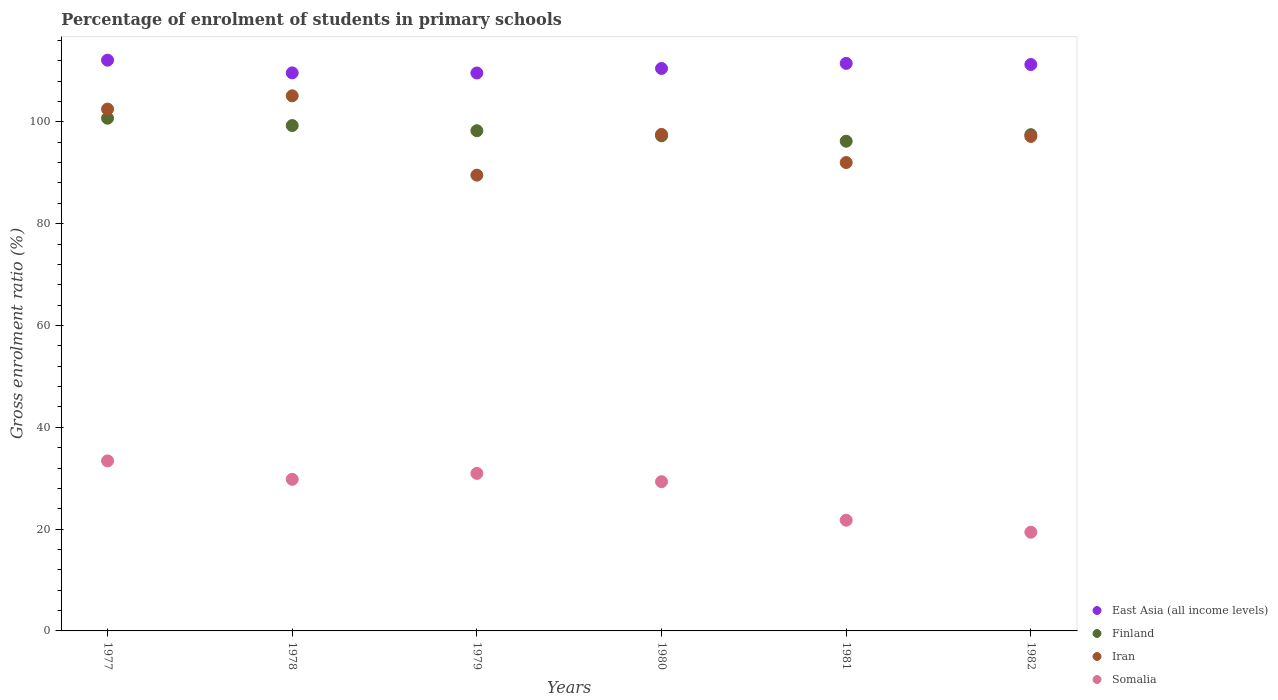What is the percentage of students enrolled in primary schools in East Asia (all income levels) in 1977?
Offer a terse response. 112.12. Across all years, what is the maximum percentage of students enrolled in primary schools in Iran?
Offer a terse response. 105.12. Across all years, what is the minimum percentage of students enrolled in primary schools in Somalia?
Provide a succinct answer. 19.39. In which year was the percentage of students enrolled in primary schools in Iran minimum?
Keep it short and to the point. 1979. What is the total percentage of students enrolled in primary schools in Iran in the graph?
Your answer should be very brief. 583.87. What is the difference between the percentage of students enrolled in primary schools in Somalia in 1978 and that in 1980?
Provide a succinct answer. 0.47. What is the difference between the percentage of students enrolled in primary schools in East Asia (all income levels) in 1978 and the percentage of students enrolled in primary schools in Finland in 1980?
Provide a succinct answer. 12.36. What is the average percentage of students enrolled in primary schools in Somalia per year?
Your answer should be compact. 27.43. In the year 1982, what is the difference between the percentage of students enrolled in primary schools in Iran and percentage of students enrolled in primary schools in Somalia?
Give a very brief answer. 77.75. What is the ratio of the percentage of students enrolled in primary schools in East Asia (all income levels) in 1977 to that in 1981?
Provide a short and direct response. 1.01. What is the difference between the highest and the second highest percentage of students enrolled in primary schools in East Asia (all income levels)?
Your answer should be very brief. 0.63. What is the difference between the highest and the lowest percentage of students enrolled in primary schools in Finland?
Offer a terse response. 4.52. Is the sum of the percentage of students enrolled in primary schools in Iran in 1980 and 1982 greater than the maximum percentage of students enrolled in primary schools in East Asia (all income levels) across all years?
Ensure brevity in your answer.  Yes. Is it the case that in every year, the sum of the percentage of students enrolled in primary schools in Somalia and percentage of students enrolled in primary schools in Iran  is greater than the sum of percentage of students enrolled in primary schools in Finland and percentage of students enrolled in primary schools in East Asia (all income levels)?
Keep it short and to the point. Yes. Is the percentage of students enrolled in primary schools in Iran strictly greater than the percentage of students enrolled in primary schools in Finland over the years?
Keep it short and to the point. No. Is the percentage of students enrolled in primary schools in Finland strictly less than the percentage of students enrolled in primary schools in Iran over the years?
Keep it short and to the point. No. What is the difference between two consecutive major ticks on the Y-axis?
Give a very brief answer. 20. Are the values on the major ticks of Y-axis written in scientific E-notation?
Give a very brief answer. No. What is the title of the graph?
Your response must be concise. Percentage of enrolment of students in primary schools. Does "Mauritania" appear as one of the legend labels in the graph?
Keep it short and to the point. No. What is the label or title of the X-axis?
Provide a succinct answer. Years. What is the Gross enrolment ratio (%) of East Asia (all income levels) in 1977?
Provide a short and direct response. 112.12. What is the Gross enrolment ratio (%) of Finland in 1977?
Ensure brevity in your answer.  100.72. What is the Gross enrolment ratio (%) in Iran in 1977?
Offer a very short reply. 102.51. What is the Gross enrolment ratio (%) of Somalia in 1977?
Offer a terse response. 33.4. What is the Gross enrolment ratio (%) in East Asia (all income levels) in 1978?
Your answer should be very brief. 109.63. What is the Gross enrolment ratio (%) in Finland in 1978?
Offer a very short reply. 99.28. What is the Gross enrolment ratio (%) in Iran in 1978?
Your answer should be compact. 105.12. What is the Gross enrolment ratio (%) in Somalia in 1978?
Ensure brevity in your answer.  29.79. What is the Gross enrolment ratio (%) in East Asia (all income levels) in 1979?
Provide a succinct answer. 109.6. What is the Gross enrolment ratio (%) in Finland in 1979?
Provide a short and direct response. 98.26. What is the Gross enrolment ratio (%) of Iran in 1979?
Provide a short and direct response. 89.54. What is the Gross enrolment ratio (%) in Somalia in 1979?
Keep it short and to the point. 30.95. What is the Gross enrolment ratio (%) of East Asia (all income levels) in 1980?
Your answer should be very brief. 110.49. What is the Gross enrolment ratio (%) of Finland in 1980?
Provide a succinct answer. 97.27. What is the Gross enrolment ratio (%) in Iran in 1980?
Offer a terse response. 97.54. What is the Gross enrolment ratio (%) in Somalia in 1980?
Make the answer very short. 29.32. What is the Gross enrolment ratio (%) of East Asia (all income levels) in 1981?
Provide a short and direct response. 111.49. What is the Gross enrolment ratio (%) of Finland in 1981?
Keep it short and to the point. 96.2. What is the Gross enrolment ratio (%) of Iran in 1981?
Keep it short and to the point. 92.01. What is the Gross enrolment ratio (%) in Somalia in 1981?
Give a very brief answer. 21.75. What is the Gross enrolment ratio (%) of East Asia (all income levels) in 1982?
Give a very brief answer. 111.27. What is the Gross enrolment ratio (%) in Finland in 1982?
Your answer should be very brief. 97.49. What is the Gross enrolment ratio (%) of Iran in 1982?
Provide a short and direct response. 97.14. What is the Gross enrolment ratio (%) in Somalia in 1982?
Offer a very short reply. 19.39. Across all years, what is the maximum Gross enrolment ratio (%) in East Asia (all income levels)?
Give a very brief answer. 112.12. Across all years, what is the maximum Gross enrolment ratio (%) in Finland?
Provide a succinct answer. 100.72. Across all years, what is the maximum Gross enrolment ratio (%) of Iran?
Provide a short and direct response. 105.12. Across all years, what is the maximum Gross enrolment ratio (%) in Somalia?
Ensure brevity in your answer.  33.4. Across all years, what is the minimum Gross enrolment ratio (%) in East Asia (all income levels)?
Keep it short and to the point. 109.6. Across all years, what is the minimum Gross enrolment ratio (%) of Finland?
Your answer should be very brief. 96.2. Across all years, what is the minimum Gross enrolment ratio (%) in Iran?
Your response must be concise. 89.54. Across all years, what is the minimum Gross enrolment ratio (%) in Somalia?
Your response must be concise. 19.39. What is the total Gross enrolment ratio (%) in East Asia (all income levels) in the graph?
Offer a very short reply. 664.61. What is the total Gross enrolment ratio (%) in Finland in the graph?
Provide a short and direct response. 589.22. What is the total Gross enrolment ratio (%) of Iran in the graph?
Offer a terse response. 583.87. What is the total Gross enrolment ratio (%) of Somalia in the graph?
Offer a terse response. 164.59. What is the difference between the Gross enrolment ratio (%) in East Asia (all income levels) in 1977 and that in 1978?
Give a very brief answer. 2.49. What is the difference between the Gross enrolment ratio (%) of Finland in 1977 and that in 1978?
Provide a short and direct response. 1.44. What is the difference between the Gross enrolment ratio (%) of Iran in 1977 and that in 1978?
Keep it short and to the point. -2.61. What is the difference between the Gross enrolment ratio (%) of Somalia in 1977 and that in 1978?
Your answer should be compact. 3.62. What is the difference between the Gross enrolment ratio (%) in East Asia (all income levels) in 1977 and that in 1979?
Your answer should be compact. 2.52. What is the difference between the Gross enrolment ratio (%) in Finland in 1977 and that in 1979?
Provide a succinct answer. 2.46. What is the difference between the Gross enrolment ratio (%) of Iran in 1977 and that in 1979?
Keep it short and to the point. 12.98. What is the difference between the Gross enrolment ratio (%) in Somalia in 1977 and that in 1979?
Keep it short and to the point. 2.45. What is the difference between the Gross enrolment ratio (%) of East Asia (all income levels) in 1977 and that in 1980?
Give a very brief answer. 1.63. What is the difference between the Gross enrolment ratio (%) in Finland in 1977 and that in 1980?
Your answer should be compact. 3.45. What is the difference between the Gross enrolment ratio (%) in Iran in 1977 and that in 1980?
Offer a terse response. 4.97. What is the difference between the Gross enrolment ratio (%) in Somalia in 1977 and that in 1980?
Offer a very short reply. 4.08. What is the difference between the Gross enrolment ratio (%) of East Asia (all income levels) in 1977 and that in 1981?
Provide a short and direct response. 0.63. What is the difference between the Gross enrolment ratio (%) in Finland in 1977 and that in 1981?
Keep it short and to the point. 4.52. What is the difference between the Gross enrolment ratio (%) in Iran in 1977 and that in 1981?
Provide a short and direct response. 10.5. What is the difference between the Gross enrolment ratio (%) in Somalia in 1977 and that in 1981?
Offer a terse response. 11.65. What is the difference between the Gross enrolment ratio (%) of East Asia (all income levels) in 1977 and that in 1982?
Offer a very short reply. 0.85. What is the difference between the Gross enrolment ratio (%) in Finland in 1977 and that in 1982?
Your response must be concise. 3.23. What is the difference between the Gross enrolment ratio (%) in Iran in 1977 and that in 1982?
Your answer should be very brief. 5.37. What is the difference between the Gross enrolment ratio (%) of Somalia in 1977 and that in 1982?
Give a very brief answer. 14.01. What is the difference between the Gross enrolment ratio (%) of East Asia (all income levels) in 1978 and that in 1979?
Your response must be concise. 0.02. What is the difference between the Gross enrolment ratio (%) in Finland in 1978 and that in 1979?
Provide a short and direct response. 1.02. What is the difference between the Gross enrolment ratio (%) of Iran in 1978 and that in 1979?
Ensure brevity in your answer.  15.59. What is the difference between the Gross enrolment ratio (%) in Somalia in 1978 and that in 1979?
Your answer should be compact. -1.16. What is the difference between the Gross enrolment ratio (%) of East Asia (all income levels) in 1978 and that in 1980?
Ensure brevity in your answer.  -0.87. What is the difference between the Gross enrolment ratio (%) in Finland in 1978 and that in 1980?
Ensure brevity in your answer.  2.01. What is the difference between the Gross enrolment ratio (%) of Iran in 1978 and that in 1980?
Provide a succinct answer. 7.58. What is the difference between the Gross enrolment ratio (%) of Somalia in 1978 and that in 1980?
Your answer should be very brief. 0.47. What is the difference between the Gross enrolment ratio (%) of East Asia (all income levels) in 1978 and that in 1981?
Offer a terse response. -1.86. What is the difference between the Gross enrolment ratio (%) in Finland in 1978 and that in 1981?
Offer a very short reply. 3.08. What is the difference between the Gross enrolment ratio (%) of Iran in 1978 and that in 1981?
Make the answer very short. 13.11. What is the difference between the Gross enrolment ratio (%) of Somalia in 1978 and that in 1981?
Provide a short and direct response. 8.04. What is the difference between the Gross enrolment ratio (%) of East Asia (all income levels) in 1978 and that in 1982?
Ensure brevity in your answer.  -1.64. What is the difference between the Gross enrolment ratio (%) in Finland in 1978 and that in 1982?
Provide a succinct answer. 1.79. What is the difference between the Gross enrolment ratio (%) of Iran in 1978 and that in 1982?
Give a very brief answer. 7.98. What is the difference between the Gross enrolment ratio (%) in Somalia in 1978 and that in 1982?
Keep it short and to the point. 10.4. What is the difference between the Gross enrolment ratio (%) in East Asia (all income levels) in 1979 and that in 1980?
Keep it short and to the point. -0.89. What is the difference between the Gross enrolment ratio (%) in Iran in 1979 and that in 1980?
Provide a succinct answer. -8.01. What is the difference between the Gross enrolment ratio (%) of Somalia in 1979 and that in 1980?
Give a very brief answer. 1.63. What is the difference between the Gross enrolment ratio (%) in East Asia (all income levels) in 1979 and that in 1981?
Your response must be concise. -1.89. What is the difference between the Gross enrolment ratio (%) in Finland in 1979 and that in 1981?
Keep it short and to the point. 2.06. What is the difference between the Gross enrolment ratio (%) in Iran in 1979 and that in 1981?
Your answer should be compact. -2.48. What is the difference between the Gross enrolment ratio (%) in Somalia in 1979 and that in 1981?
Your answer should be compact. 9.2. What is the difference between the Gross enrolment ratio (%) in East Asia (all income levels) in 1979 and that in 1982?
Keep it short and to the point. -1.67. What is the difference between the Gross enrolment ratio (%) in Finland in 1979 and that in 1982?
Provide a short and direct response. 0.77. What is the difference between the Gross enrolment ratio (%) in Iran in 1979 and that in 1982?
Make the answer very short. -7.61. What is the difference between the Gross enrolment ratio (%) in Somalia in 1979 and that in 1982?
Give a very brief answer. 11.56. What is the difference between the Gross enrolment ratio (%) of East Asia (all income levels) in 1980 and that in 1981?
Your answer should be compact. -1. What is the difference between the Gross enrolment ratio (%) in Finland in 1980 and that in 1981?
Offer a very short reply. 1.07. What is the difference between the Gross enrolment ratio (%) in Iran in 1980 and that in 1981?
Your answer should be very brief. 5.53. What is the difference between the Gross enrolment ratio (%) of Somalia in 1980 and that in 1981?
Offer a very short reply. 7.57. What is the difference between the Gross enrolment ratio (%) in East Asia (all income levels) in 1980 and that in 1982?
Give a very brief answer. -0.78. What is the difference between the Gross enrolment ratio (%) in Finland in 1980 and that in 1982?
Ensure brevity in your answer.  -0.22. What is the difference between the Gross enrolment ratio (%) of Iran in 1980 and that in 1982?
Your answer should be very brief. 0.4. What is the difference between the Gross enrolment ratio (%) of Somalia in 1980 and that in 1982?
Offer a very short reply. 9.93. What is the difference between the Gross enrolment ratio (%) of East Asia (all income levels) in 1981 and that in 1982?
Keep it short and to the point. 0.22. What is the difference between the Gross enrolment ratio (%) in Finland in 1981 and that in 1982?
Provide a succinct answer. -1.29. What is the difference between the Gross enrolment ratio (%) of Iran in 1981 and that in 1982?
Give a very brief answer. -5.13. What is the difference between the Gross enrolment ratio (%) of Somalia in 1981 and that in 1982?
Offer a terse response. 2.36. What is the difference between the Gross enrolment ratio (%) in East Asia (all income levels) in 1977 and the Gross enrolment ratio (%) in Finland in 1978?
Offer a very short reply. 12.84. What is the difference between the Gross enrolment ratio (%) in East Asia (all income levels) in 1977 and the Gross enrolment ratio (%) in Iran in 1978?
Offer a terse response. 7. What is the difference between the Gross enrolment ratio (%) of East Asia (all income levels) in 1977 and the Gross enrolment ratio (%) of Somalia in 1978?
Make the answer very short. 82.34. What is the difference between the Gross enrolment ratio (%) in Finland in 1977 and the Gross enrolment ratio (%) in Iran in 1978?
Offer a very short reply. -4.4. What is the difference between the Gross enrolment ratio (%) in Finland in 1977 and the Gross enrolment ratio (%) in Somalia in 1978?
Make the answer very short. 70.94. What is the difference between the Gross enrolment ratio (%) of Iran in 1977 and the Gross enrolment ratio (%) of Somalia in 1978?
Your response must be concise. 72.73. What is the difference between the Gross enrolment ratio (%) of East Asia (all income levels) in 1977 and the Gross enrolment ratio (%) of Finland in 1979?
Offer a very short reply. 13.86. What is the difference between the Gross enrolment ratio (%) in East Asia (all income levels) in 1977 and the Gross enrolment ratio (%) in Iran in 1979?
Make the answer very short. 22.59. What is the difference between the Gross enrolment ratio (%) in East Asia (all income levels) in 1977 and the Gross enrolment ratio (%) in Somalia in 1979?
Give a very brief answer. 81.17. What is the difference between the Gross enrolment ratio (%) of Finland in 1977 and the Gross enrolment ratio (%) of Iran in 1979?
Your answer should be compact. 11.19. What is the difference between the Gross enrolment ratio (%) of Finland in 1977 and the Gross enrolment ratio (%) of Somalia in 1979?
Provide a succinct answer. 69.77. What is the difference between the Gross enrolment ratio (%) of Iran in 1977 and the Gross enrolment ratio (%) of Somalia in 1979?
Give a very brief answer. 71.57. What is the difference between the Gross enrolment ratio (%) of East Asia (all income levels) in 1977 and the Gross enrolment ratio (%) of Finland in 1980?
Ensure brevity in your answer.  14.85. What is the difference between the Gross enrolment ratio (%) in East Asia (all income levels) in 1977 and the Gross enrolment ratio (%) in Iran in 1980?
Offer a very short reply. 14.58. What is the difference between the Gross enrolment ratio (%) in East Asia (all income levels) in 1977 and the Gross enrolment ratio (%) in Somalia in 1980?
Provide a succinct answer. 82.8. What is the difference between the Gross enrolment ratio (%) of Finland in 1977 and the Gross enrolment ratio (%) of Iran in 1980?
Your answer should be compact. 3.18. What is the difference between the Gross enrolment ratio (%) of Finland in 1977 and the Gross enrolment ratio (%) of Somalia in 1980?
Provide a succinct answer. 71.4. What is the difference between the Gross enrolment ratio (%) in Iran in 1977 and the Gross enrolment ratio (%) in Somalia in 1980?
Offer a terse response. 73.2. What is the difference between the Gross enrolment ratio (%) of East Asia (all income levels) in 1977 and the Gross enrolment ratio (%) of Finland in 1981?
Your response must be concise. 15.92. What is the difference between the Gross enrolment ratio (%) in East Asia (all income levels) in 1977 and the Gross enrolment ratio (%) in Iran in 1981?
Provide a short and direct response. 20.11. What is the difference between the Gross enrolment ratio (%) of East Asia (all income levels) in 1977 and the Gross enrolment ratio (%) of Somalia in 1981?
Keep it short and to the point. 90.37. What is the difference between the Gross enrolment ratio (%) in Finland in 1977 and the Gross enrolment ratio (%) in Iran in 1981?
Your answer should be very brief. 8.71. What is the difference between the Gross enrolment ratio (%) of Finland in 1977 and the Gross enrolment ratio (%) of Somalia in 1981?
Ensure brevity in your answer.  78.97. What is the difference between the Gross enrolment ratio (%) in Iran in 1977 and the Gross enrolment ratio (%) in Somalia in 1981?
Provide a short and direct response. 80.77. What is the difference between the Gross enrolment ratio (%) of East Asia (all income levels) in 1977 and the Gross enrolment ratio (%) of Finland in 1982?
Offer a terse response. 14.63. What is the difference between the Gross enrolment ratio (%) of East Asia (all income levels) in 1977 and the Gross enrolment ratio (%) of Iran in 1982?
Make the answer very short. 14.98. What is the difference between the Gross enrolment ratio (%) in East Asia (all income levels) in 1977 and the Gross enrolment ratio (%) in Somalia in 1982?
Offer a terse response. 92.73. What is the difference between the Gross enrolment ratio (%) of Finland in 1977 and the Gross enrolment ratio (%) of Iran in 1982?
Offer a terse response. 3.58. What is the difference between the Gross enrolment ratio (%) of Finland in 1977 and the Gross enrolment ratio (%) of Somalia in 1982?
Ensure brevity in your answer.  81.33. What is the difference between the Gross enrolment ratio (%) of Iran in 1977 and the Gross enrolment ratio (%) of Somalia in 1982?
Keep it short and to the point. 83.13. What is the difference between the Gross enrolment ratio (%) of East Asia (all income levels) in 1978 and the Gross enrolment ratio (%) of Finland in 1979?
Provide a short and direct response. 11.37. What is the difference between the Gross enrolment ratio (%) in East Asia (all income levels) in 1978 and the Gross enrolment ratio (%) in Iran in 1979?
Offer a very short reply. 20.09. What is the difference between the Gross enrolment ratio (%) of East Asia (all income levels) in 1978 and the Gross enrolment ratio (%) of Somalia in 1979?
Your answer should be very brief. 78.68. What is the difference between the Gross enrolment ratio (%) in Finland in 1978 and the Gross enrolment ratio (%) in Iran in 1979?
Your response must be concise. 9.74. What is the difference between the Gross enrolment ratio (%) in Finland in 1978 and the Gross enrolment ratio (%) in Somalia in 1979?
Make the answer very short. 68.33. What is the difference between the Gross enrolment ratio (%) of Iran in 1978 and the Gross enrolment ratio (%) of Somalia in 1979?
Keep it short and to the point. 74.17. What is the difference between the Gross enrolment ratio (%) of East Asia (all income levels) in 1978 and the Gross enrolment ratio (%) of Finland in 1980?
Provide a short and direct response. 12.36. What is the difference between the Gross enrolment ratio (%) of East Asia (all income levels) in 1978 and the Gross enrolment ratio (%) of Iran in 1980?
Make the answer very short. 12.09. What is the difference between the Gross enrolment ratio (%) of East Asia (all income levels) in 1978 and the Gross enrolment ratio (%) of Somalia in 1980?
Provide a succinct answer. 80.31. What is the difference between the Gross enrolment ratio (%) in Finland in 1978 and the Gross enrolment ratio (%) in Iran in 1980?
Keep it short and to the point. 1.74. What is the difference between the Gross enrolment ratio (%) of Finland in 1978 and the Gross enrolment ratio (%) of Somalia in 1980?
Your answer should be compact. 69.96. What is the difference between the Gross enrolment ratio (%) of Iran in 1978 and the Gross enrolment ratio (%) of Somalia in 1980?
Your answer should be very brief. 75.8. What is the difference between the Gross enrolment ratio (%) in East Asia (all income levels) in 1978 and the Gross enrolment ratio (%) in Finland in 1981?
Your answer should be very brief. 13.43. What is the difference between the Gross enrolment ratio (%) in East Asia (all income levels) in 1978 and the Gross enrolment ratio (%) in Iran in 1981?
Provide a succinct answer. 17.61. What is the difference between the Gross enrolment ratio (%) of East Asia (all income levels) in 1978 and the Gross enrolment ratio (%) of Somalia in 1981?
Keep it short and to the point. 87.88. What is the difference between the Gross enrolment ratio (%) in Finland in 1978 and the Gross enrolment ratio (%) in Iran in 1981?
Give a very brief answer. 7.27. What is the difference between the Gross enrolment ratio (%) of Finland in 1978 and the Gross enrolment ratio (%) of Somalia in 1981?
Provide a short and direct response. 77.53. What is the difference between the Gross enrolment ratio (%) of Iran in 1978 and the Gross enrolment ratio (%) of Somalia in 1981?
Offer a very short reply. 83.37. What is the difference between the Gross enrolment ratio (%) of East Asia (all income levels) in 1978 and the Gross enrolment ratio (%) of Finland in 1982?
Offer a terse response. 12.14. What is the difference between the Gross enrolment ratio (%) of East Asia (all income levels) in 1978 and the Gross enrolment ratio (%) of Iran in 1982?
Your answer should be very brief. 12.49. What is the difference between the Gross enrolment ratio (%) in East Asia (all income levels) in 1978 and the Gross enrolment ratio (%) in Somalia in 1982?
Provide a short and direct response. 90.24. What is the difference between the Gross enrolment ratio (%) in Finland in 1978 and the Gross enrolment ratio (%) in Iran in 1982?
Give a very brief answer. 2.14. What is the difference between the Gross enrolment ratio (%) in Finland in 1978 and the Gross enrolment ratio (%) in Somalia in 1982?
Offer a very short reply. 79.89. What is the difference between the Gross enrolment ratio (%) of Iran in 1978 and the Gross enrolment ratio (%) of Somalia in 1982?
Keep it short and to the point. 85.73. What is the difference between the Gross enrolment ratio (%) of East Asia (all income levels) in 1979 and the Gross enrolment ratio (%) of Finland in 1980?
Your answer should be compact. 12.33. What is the difference between the Gross enrolment ratio (%) in East Asia (all income levels) in 1979 and the Gross enrolment ratio (%) in Iran in 1980?
Your answer should be very brief. 12.06. What is the difference between the Gross enrolment ratio (%) of East Asia (all income levels) in 1979 and the Gross enrolment ratio (%) of Somalia in 1980?
Your response must be concise. 80.29. What is the difference between the Gross enrolment ratio (%) of Finland in 1979 and the Gross enrolment ratio (%) of Iran in 1980?
Ensure brevity in your answer.  0.72. What is the difference between the Gross enrolment ratio (%) of Finland in 1979 and the Gross enrolment ratio (%) of Somalia in 1980?
Your answer should be compact. 68.94. What is the difference between the Gross enrolment ratio (%) in Iran in 1979 and the Gross enrolment ratio (%) in Somalia in 1980?
Offer a terse response. 60.22. What is the difference between the Gross enrolment ratio (%) of East Asia (all income levels) in 1979 and the Gross enrolment ratio (%) of Finland in 1981?
Your answer should be very brief. 13.4. What is the difference between the Gross enrolment ratio (%) of East Asia (all income levels) in 1979 and the Gross enrolment ratio (%) of Iran in 1981?
Ensure brevity in your answer.  17.59. What is the difference between the Gross enrolment ratio (%) in East Asia (all income levels) in 1979 and the Gross enrolment ratio (%) in Somalia in 1981?
Provide a succinct answer. 87.85. What is the difference between the Gross enrolment ratio (%) of Finland in 1979 and the Gross enrolment ratio (%) of Iran in 1981?
Ensure brevity in your answer.  6.25. What is the difference between the Gross enrolment ratio (%) in Finland in 1979 and the Gross enrolment ratio (%) in Somalia in 1981?
Offer a very short reply. 76.51. What is the difference between the Gross enrolment ratio (%) of Iran in 1979 and the Gross enrolment ratio (%) of Somalia in 1981?
Offer a terse response. 67.79. What is the difference between the Gross enrolment ratio (%) in East Asia (all income levels) in 1979 and the Gross enrolment ratio (%) in Finland in 1982?
Give a very brief answer. 12.12. What is the difference between the Gross enrolment ratio (%) in East Asia (all income levels) in 1979 and the Gross enrolment ratio (%) in Iran in 1982?
Your answer should be compact. 12.46. What is the difference between the Gross enrolment ratio (%) of East Asia (all income levels) in 1979 and the Gross enrolment ratio (%) of Somalia in 1982?
Provide a succinct answer. 90.21. What is the difference between the Gross enrolment ratio (%) in Finland in 1979 and the Gross enrolment ratio (%) in Iran in 1982?
Make the answer very short. 1.12. What is the difference between the Gross enrolment ratio (%) of Finland in 1979 and the Gross enrolment ratio (%) of Somalia in 1982?
Provide a succinct answer. 78.87. What is the difference between the Gross enrolment ratio (%) of Iran in 1979 and the Gross enrolment ratio (%) of Somalia in 1982?
Keep it short and to the point. 70.15. What is the difference between the Gross enrolment ratio (%) in East Asia (all income levels) in 1980 and the Gross enrolment ratio (%) in Finland in 1981?
Provide a short and direct response. 14.29. What is the difference between the Gross enrolment ratio (%) in East Asia (all income levels) in 1980 and the Gross enrolment ratio (%) in Iran in 1981?
Your answer should be very brief. 18.48. What is the difference between the Gross enrolment ratio (%) in East Asia (all income levels) in 1980 and the Gross enrolment ratio (%) in Somalia in 1981?
Your response must be concise. 88.74. What is the difference between the Gross enrolment ratio (%) of Finland in 1980 and the Gross enrolment ratio (%) of Iran in 1981?
Ensure brevity in your answer.  5.25. What is the difference between the Gross enrolment ratio (%) in Finland in 1980 and the Gross enrolment ratio (%) in Somalia in 1981?
Give a very brief answer. 75.52. What is the difference between the Gross enrolment ratio (%) of Iran in 1980 and the Gross enrolment ratio (%) of Somalia in 1981?
Ensure brevity in your answer.  75.79. What is the difference between the Gross enrolment ratio (%) in East Asia (all income levels) in 1980 and the Gross enrolment ratio (%) in Finland in 1982?
Your response must be concise. 13.01. What is the difference between the Gross enrolment ratio (%) of East Asia (all income levels) in 1980 and the Gross enrolment ratio (%) of Iran in 1982?
Your response must be concise. 13.35. What is the difference between the Gross enrolment ratio (%) of East Asia (all income levels) in 1980 and the Gross enrolment ratio (%) of Somalia in 1982?
Offer a very short reply. 91.11. What is the difference between the Gross enrolment ratio (%) in Finland in 1980 and the Gross enrolment ratio (%) in Iran in 1982?
Give a very brief answer. 0.13. What is the difference between the Gross enrolment ratio (%) of Finland in 1980 and the Gross enrolment ratio (%) of Somalia in 1982?
Give a very brief answer. 77.88. What is the difference between the Gross enrolment ratio (%) of Iran in 1980 and the Gross enrolment ratio (%) of Somalia in 1982?
Provide a short and direct response. 78.15. What is the difference between the Gross enrolment ratio (%) of East Asia (all income levels) in 1981 and the Gross enrolment ratio (%) of Finland in 1982?
Your answer should be very brief. 14. What is the difference between the Gross enrolment ratio (%) in East Asia (all income levels) in 1981 and the Gross enrolment ratio (%) in Iran in 1982?
Provide a short and direct response. 14.35. What is the difference between the Gross enrolment ratio (%) in East Asia (all income levels) in 1981 and the Gross enrolment ratio (%) in Somalia in 1982?
Your response must be concise. 92.1. What is the difference between the Gross enrolment ratio (%) of Finland in 1981 and the Gross enrolment ratio (%) of Iran in 1982?
Your response must be concise. -0.94. What is the difference between the Gross enrolment ratio (%) in Finland in 1981 and the Gross enrolment ratio (%) in Somalia in 1982?
Provide a short and direct response. 76.81. What is the difference between the Gross enrolment ratio (%) in Iran in 1981 and the Gross enrolment ratio (%) in Somalia in 1982?
Offer a very short reply. 72.63. What is the average Gross enrolment ratio (%) of East Asia (all income levels) per year?
Give a very brief answer. 110.77. What is the average Gross enrolment ratio (%) of Finland per year?
Provide a succinct answer. 98.2. What is the average Gross enrolment ratio (%) in Iran per year?
Keep it short and to the point. 97.31. What is the average Gross enrolment ratio (%) in Somalia per year?
Keep it short and to the point. 27.43. In the year 1977, what is the difference between the Gross enrolment ratio (%) in East Asia (all income levels) and Gross enrolment ratio (%) in Finland?
Your answer should be compact. 11.4. In the year 1977, what is the difference between the Gross enrolment ratio (%) in East Asia (all income levels) and Gross enrolment ratio (%) in Iran?
Ensure brevity in your answer.  9.61. In the year 1977, what is the difference between the Gross enrolment ratio (%) in East Asia (all income levels) and Gross enrolment ratio (%) in Somalia?
Give a very brief answer. 78.72. In the year 1977, what is the difference between the Gross enrolment ratio (%) in Finland and Gross enrolment ratio (%) in Iran?
Offer a terse response. -1.79. In the year 1977, what is the difference between the Gross enrolment ratio (%) in Finland and Gross enrolment ratio (%) in Somalia?
Offer a very short reply. 67.32. In the year 1977, what is the difference between the Gross enrolment ratio (%) in Iran and Gross enrolment ratio (%) in Somalia?
Your response must be concise. 69.11. In the year 1978, what is the difference between the Gross enrolment ratio (%) of East Asia (all income levels) and Gross enrolment ratio (%) of Finland?
Your response must be concise. 10.35. In the year 1978, what is the difference between the Gross enrolment ratio (%) of East Asia (all income levels) and Gross enrolment ratio (%) of Iran?
Your answer should be compact. 4.51. In the year 1978, what is the difference between the Gross enrolment ratio (%) in East Asia (all income levels) and Gross enrolment ratio (%) in Somalia?
Your answer should be compact. 79.84. In the year 1978, what is the difference between the Gross enrolment ratio (%) of Finland and Gross enrolment ratio (%) of Iran?
Provide a short and direct response. -5.84. In the year 1978, what is the difference between the Gross enrolment ratio (%) in Finland and Gross enrolment ratio (%) in Somalia?
Offer a terse response. 69.49. In the year 1978, what is the difference between the Gross enrolment ratio (%) of Iran and Gross enrolment ratio (%) of Somalia?
Provide a succinct answer. 75.34. In the year 1979, what is the difference between the Gross enrolment ratio (%) in East Asia (all income levels) and Gross enrolment ratio (%) in Finland?
Your response must be concise. 11.34. In the year 1979, what is the difference between the Gross enrolment ratio (%) of East Asia (all income levels) and Gross enrolment ratio (%) of Iran?
Offer a terse response. 20.07. In the year 1979, what is the difference between the Gross enrolment ratio (%) in East Asia (all income levels) and Gross enrolment ratio (%) in Somalia?
Ensure brevity in your answer.  78.66. In the year 1979, what is the difference between the Gross enrolment ratio (%) of Finland and Gross enrolment ratio (%) of Iran?
Your answer should be compact. 8.73. In the year 1979, what is the difference between the Gross enrolment ratio (%) in Finland and Gross enrolment ratio (%) in Somalia?
Your answer should be very brief. 67.31. In the year 1979, what is the difference between the Gross enrolment ratio (%) in Iran and Gross enrolment ratio (%) in Somalia?
Give a very brief answer. 58.59. In the year 1980, what is the difference between the Gross enrolment ratio (%) in East Asia (all income levels) and Gross enrolment ratio (%) in Finland?
Ensure brevity in your answer.  13.22. In the year 1980, what is the difference between the Gross enrolment ratio (%) in East Asia (all income levels) and Gross enrolment ratio (%) in Iran?
Ensure brevity in your answer.  12.95. In the year 1980, what is the difference between the Gross enrolment ratio (%) of East Asia (all income levels) and Gross enrolment ratio (%) of Somalia?
Your answer should be very brief. 81.18. In the year 1980, what is the difference between the Gross enrolment ratio (%) of Finland and Gross enrolment ratio (%) of Iran?
Offer a terse response. -0.27. In the year 1980, what is the difference between the Gross enrolment ratio (%) in Finland and Gross enrolment ratio (%) in Somalia?
Keep it short and to the point. 67.95. In the year 1980, what is the difference between the Gross enrolment ratio (%) in Iran and Gross enrolment ratio (%) in Somalia?
Give a very brief answer. 68.22. In the year 1981, what is the difference between the Gross enrolment ratio (%) in East Asia (all income levels) and Gross enrolment ratio (%) in Finland?
Provide a short and direct response. 15.29. In the year 1981, what is the difference between the Gross enrolment ratio (%) in East Asia (all income levels) and Gross enrolment ratio (%) in Iran?
Keep it short and to the point. 19.48. In the year 1981, what is the difference between the Gross enrolment ratio (%) in East Asia (all income levels) and Gross enrolment ratio (%) in Somalia?
Provide a short and direct response. 89.74. In the year 1981, what is the difference between the Gross enrolment ratio (%) in Finland and Gross enrolment ratio (%) in Iran?
Offer a terse response. 4.19. In the year 1981, what is the difference between the Gross enrolment ratio (%) of Finland and Gross enrolment ratio (%) of Somalia?
Provide a succinct answer. 74.45. In the year 1981, what is the difference between the Gross enrolment ratio (%) of Iran and Gross enrolment ratio (%) of Somalia?
Make the answer very short. 70.26. In the year 1982, what is the difference between the Gross enrolment ratio (%) of East Asia (all income levels) and Gross enrolment ratio (%) of Finland?
Make the answer very short. 13.78. In the year 1982, what is the difference between the Gross enrolment ratio (%) in East Asia (all income levels) and Gross enrolment ratio (%) in Iran?
Make the answer very short. 14.13. In the year 1982, what is the difference between the Gross enrolment ratio (%) of East Asia (all income levels) and Gross enrolment ratio (%) of Somalia?
Provide a succinct answer. 91.88. In the year 1982, what is the difference between the Gross enrolment ratio (%) in Finland and Gross enrolment ratio (%) in Iran?
Make the answer very short. 0.35. In the year 1982, what is the difference between the Gross enrolment ratio (%) in Finland and Gross enrolment ratio (%) in Somalia?
Ensure brevity in your answer.  78.1. In the year 1982, what is the difference between the Gross enrolment ratio (%) of Iran and Gross enrolment ratio (%) of Somalia?
Your response must be concise. 77.75. What is the ratio of the Gross enrolment ratio (%) in East Asia (all income levels) in 1977 to that in 1978?
Give a very brief answer. 1.02. What is the ratio of the Gross enrolment ratio (%) of Finland in 1977 to that in 1978?
Provide a short and direct response. 1.01. What is the ratio of the Gross enrolment ratio (%) of Iran in 1977 to that in 1978?
Ensure brevity in your answer.  0.98. What is the ratio of the Gross enrolment ratio (%) of Somalia in 1977 to that in 1978?
Your response must be concise. 1.12. What is the ratio of the Gross enrolment ratio (%) of Iran in 1977 to that in 1979?
Your answer should be very brief. 1.15. What is the ratio of the Gross enrolment ratio (%) in Somalia in 1977 to that in 1979?
Your answer should be compact. 1.08. What is the ratio of the Gross enrolment ratio (%) in East Asia (all income levels) in 1977 to that in 1980?
Keep it short and to the point. 1.01. What is the ratio of the Gross enrolment ratio (%) of Finland in 1977 to that in 1980?
Your response must be concise. 1.04. What is the ratio of the Gross enrolment ratio (%) of Iran in 1977 to that in 1980?
Offer a terse response. 1.05. What is the ratio of the Gross enrolment ratio (%) in Somalia in 1977 to that in 1980?
Your answer should be very brief. 1.14. What is the ratio of the Gross enrolment ratio (%) in East Asia (all income levels) in 1977 to that in 1981?
Ensure brevity in your answer.  1.01. What is the ratio of the Gross enrolment ratio (%) in Finland in 1977 to that in 1981?
Your answer should be compact. 1.05. What is the ratio of the Gross enrolment ratio (%) of Iran in 1977 to that in 1981?
Provide a succinct answer. 1.11. What is the ratio of the Gross enrolment ratio (%) of Somalia in 1977 to that in 1981?
Make the answer very short. 1.54. What is the ratio of the Gross enrolment ratio (%) of East Asia (all income levels) in 1977 to that in 1982?
Offer a terse response. 1.01. What is the ratio of the Gross enrolment ratio (%) in Finland in 1977 to that in 1982?
Provide a succinct answer. 1.03. What is the ratio of the Gross enrolment ratio (%) in Iran in 1977 to that in 1982?
Your answer should be compact. 1.06. What is the ratio of the Gross enrolment ratio (%) in Somalia in 1977 to that in 1982?
Your response must be concise. 1.72. What is the ratio of the Gross enrolment ratio (%) in Finland in 1978 to that in 1979?
Offer a terse response. 1.01. What is the ratio of the Gross enrolment ratio (%) of Iran in 1978 to that in 1979?
Your answer should be compact. 1.17. What is the ratio of the Gross enrolment ratio (%) of Somalia in 1978 to that in 1979?
Provide a short and direct response. 0.96. What is the ratio of the Gross enrolment ratio (%) in East Asia (all income levels) in 1978 to that in 1980?
Make the answer very short. 0.99. What is the ratio of the Gross enrolment ratio (%) in Finland in 1978 to that in 1980?
Your answer should be compact. 1.02. What is the ratio of the Gross enrolment ratio (%) in Iran in 1978 to that in 1980?
Your answer should be very brief. 1.08. What is the ratio of the Gross enrolment ratio (%) of Somalia in 1978 to that in 1980?
Your answer should be very brief. 1.02. What is the ratio of the Gross enrolment ratio (%) of East Asia (all income levels) in 1978 to that in 1981?
Offer a very short reply. 0.98. What is the ratio of the Gross enrolment ratio (%) in Finland in 1978 to that in 1981?
Provide a short and direct response. 1.03. What is the ratio of the Gross enrolment ratio (%) of Iran in 1978 to that in 1981?
Your answer should be compact. 1.14. What is the ratio of the Gross enrolment ratio (%) of Somalia in 1978 to that in 1981?
Your answer should be very brief. 1.37. What is the ratio of the Gross enrolment ratio (%) in East Asia (all income levels) in 1978 to that in 1982?
Your answer should be compact. 0.99. What is the ratio of the Gross enrolment ratio (%) in Finland in 1978 to that in 1982?
Your response must be concise. 1.02. What is the ratio of the Gross enrolment ratio (%) of Iran in 1978 to that in 1982?
Ensure brevity in your answer.  1.08. What is the ratio of the Gross enrolment ratio (%) in Somalia in 1978 to that in 1982?
Give a very brief answer. 1.54. What is the ratio of the Gross enrolment ratio (%) in Finland in 1979 to that in 1980?
Offer a very short reply. 1.01. What is the ratio of the Gross enrolment ratio (%) of Iran in 1979 to that in 1980?
Provide a succinct answer. 0.92. What is the ratio of the Gross enrolment ratio (%) of Somalia in 1979 to that in 1980?
Your answer should be compact. 1.06. What is the ratio of the Gross enrolment ratio (%) of East Asia (all income levels) in 1979 to that in 1981?
Your response must be concise. 0.98. What is the ratio of the Gross enrolment ratio (%) of Finland in 1979 to that in 1981?
Your answer should be very brief. 1.02. What is the ratio of the Gross enrolment ratio (%) in Iran in 1979 to that in 1981?
Make the answer very short. 0.97. What is the ratio of the Gross enrolment ratio (%) of Somalia in 1979 to that in 1981?
Your answer should be compact. 1.42. What is the ratio of the Gross enrolment ratio (%) of Finland in 1979 to that in 1982?
Offer a very short reply. 1.01. What is the ratio of the Gross enrolment ratio (%) in Iran in 1979 to that in 1982?
Ensure brevity in your answer.  0.92. What is the ratio of the Gross enrolment ratio (%) in Somalia in 1979 to that in 1982?
Offer a terse response. 1.6. What is the ratio of the Gross enrolment ratio (%) in Finland in 1980 to that in 1981?
Keep it short and to the point. 1.01. What is the ratio of the Gross enrolment ratio (%) in Iran in 1980 to that in 1981?
Make the answer very short. 1.06. What is the ratio of the Gross enrolment ratio (%) of Somalia in 1980 to that in 1981?
Offer a terse response. 1.35. What is the ratio of the Gross enrolment ratio (%) in Finland in 1980 to that in 1982?
Ensure brevity in your answer.  1. What is the ratio of the Gross enrolment ratio (%) in Somalia in 1980 to that in 1982?
Provide a short and direct response. 1.51. What is the ratio of the Gross enrolment ratio (%) of East Asia (all income levels) in 1981 to that in 1982?
Ensure brevity in your answer.  1. What is the ratio of the Gross enrolment ratio (%) of Iran in 1981 to that in 1982?
Keep it short and to the point. 0.95. What is the ratio of the Gross enrolment ratio (%) of Somalia in 1981 to that in 1982?
Ensure brevity in your answer.  1.12. What is the difference between the highest and the second highest Gross enrolment ratio (%) in East Asia (all income levels)?
Your answer should be compact. 0.63. What is the difference between the highest and the second highest Gross enrolment ratio (%) in Finland?
Offer a very short reply. 1.44. What is the difference between the highest and the second highest Gross enrolment ratio (%) of Iran?
Offer a very short reply. 2.61. What is the difference between the highest and the second highest Gross enrolment ratio (%) in Somalia?
Keep it short and to the point. 2.45. What is the difference between the highest and the lowest Gross enrolment ratio (%) in East Asia (all income levels)?
Offer a very short reply. 2.52. What is the difference between the highest and the lowest Gross enrolment ratio (%) of Finland?
Offer a very short reply. 4.52. What is the difference between the highest and the lowest Gross enrolment ratio (%) in Iran?
Offer a terse response. 15.59. What is the difference between the highest and the lowest Gross enrolment ratio (%) of Somalia?
Ensure brevity in your answer.  14.01. 